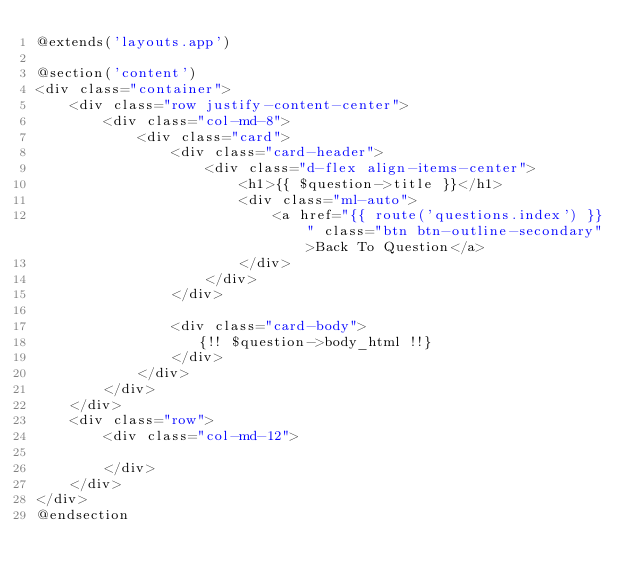Convert code to text. <code><loc_0><loc_0><loc_500><loc_500><_PHP_>@extends('layouts.app')

@section('content')
<div class="container">
    <div class="row justify-content-center">
        <div class="col-md-8">
            <div class="card">
                <div class="card-header">
                    <div class="d-flex align-items-center">
                        <h1>{{ $question->title }}</h1>
                        <div class="ml-auto">
                            <a href="{{ route('questions.index') }}" class="btn btn-outline-secondary">Back To Question</a>
                        </div>
                    </div>
                </div>

                <div class="card-body">
                   {!! $question->body_html !!}
                </div>    
            </div>
        </div>
    </div>
    <div class="row">
        <div class="col-md-12">
            
        </div>
    </div>
</div>
@endsection
</code> 